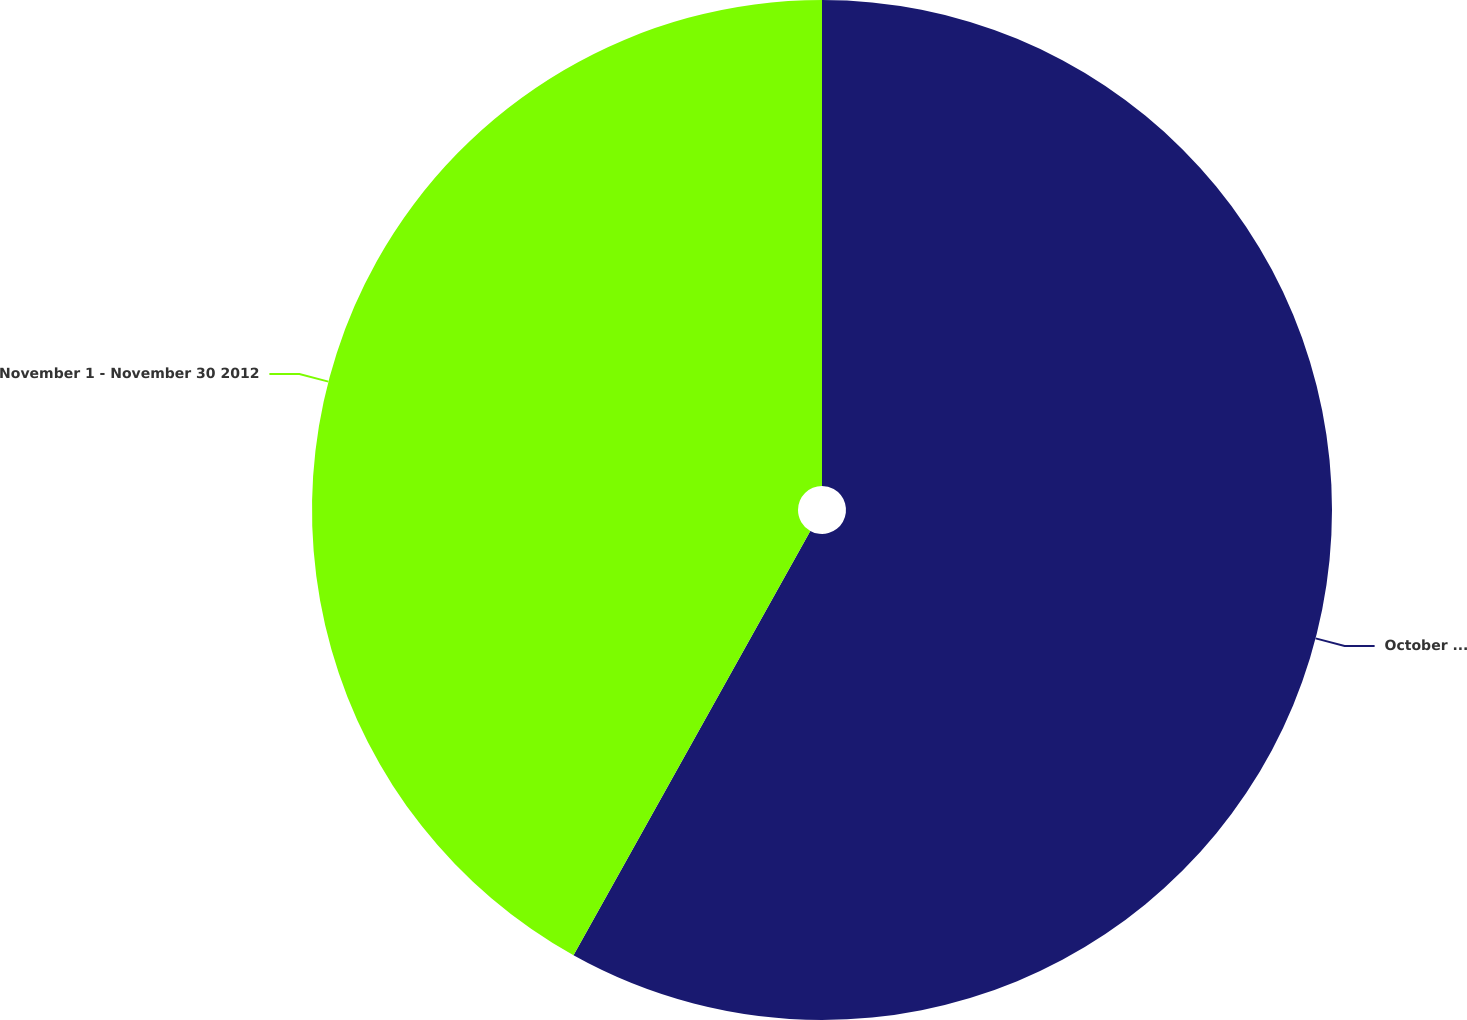<chart> <loc_0><loc_0><loc_500><loc_500><pie_chart><fcel>October 1 - October 31 2012<fcel>November 1 - November 30 2012<nl><fcel>58.1%<fcel>41.9%<nl></chart> 